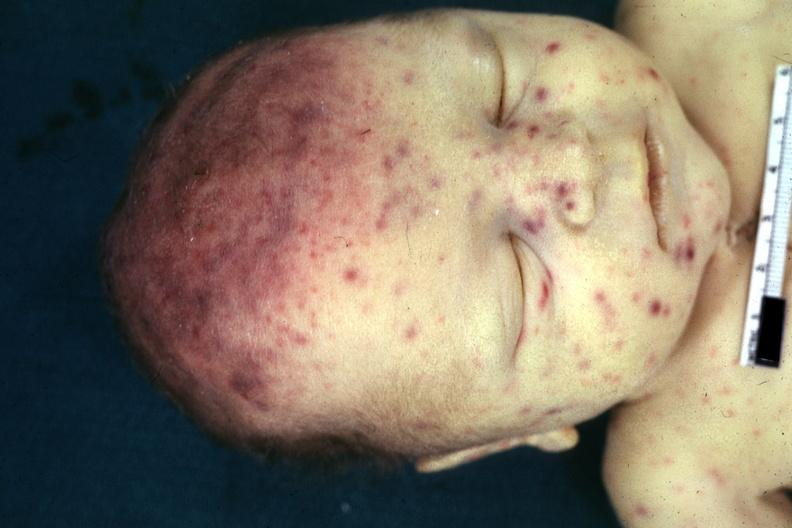s ameloblastoma present?
Answer the question using a single word or phrase. No 